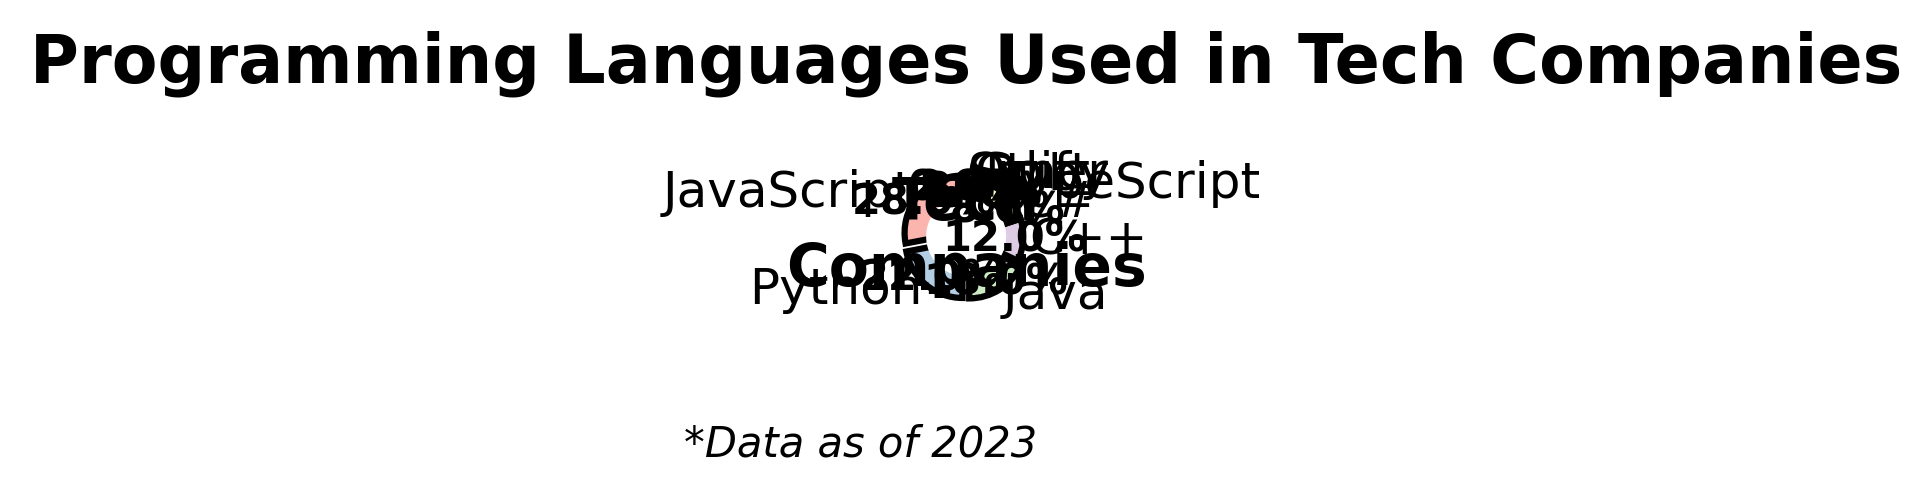What percentage of tech companies use JavaScript? According to the pie chart, the section labeled "JavaScript" shows a percentage value.
Answer: 28% How does the percentage of JavaScript compare to Python? The pie chart shows that JavaScript is at 28% and Python is at 22%. By comparing these numbers, we can see that JavaScript has a higher percentage.
Answer: JavaScript > Python What's the total percentage for Java and C++ combined? The pie chart indicates Java at 18% and C++ at 12%. Adding these values together: 18% + 12% = 30%
Answer: 30% Which language has the smallest slice in the pie chart and what is its percentage? The pie chart shows small slices for languages, and the smallest slice is labeled "Swift" with 1%.
Answer: Swift, 1% What is the difference in percentage between the highest and lowest represented languages? The highest percentage is for JavaScript at 28%, and the lowest is for Swift at 1%. The difference is calculated as 28% - 1% = 27%.
Answer: 27% If you combine the percentages for Java, C++, and Python, what is their total representation? The pie chart shows Java at 18%, C++ at 12%, and Python at 22%. Adding these values: 18% + 12% + 22% = 52%
Answer: 52% Are there more companies using Python and Java combined or JavaScript? Python and Java combined is 22% + 18% = 40%, while JavaScript alone is 28%. Therefore, Python and Java combined have a higher percentage.
Answer: Python and Java combined Which language occupies the bright pink slice and what is its percentage? The bright pink slice corresponds to Java, as identified by its label on the pie chart showing 18%.
Answer: Java, 18% How does the use of Go compare with the use of Ruby in tech companies? The pie chart shows Go at 2% and Ruby at 3%. By comparison, Ruby has a higher percentage than Go.
Answer: Ruby > Go 